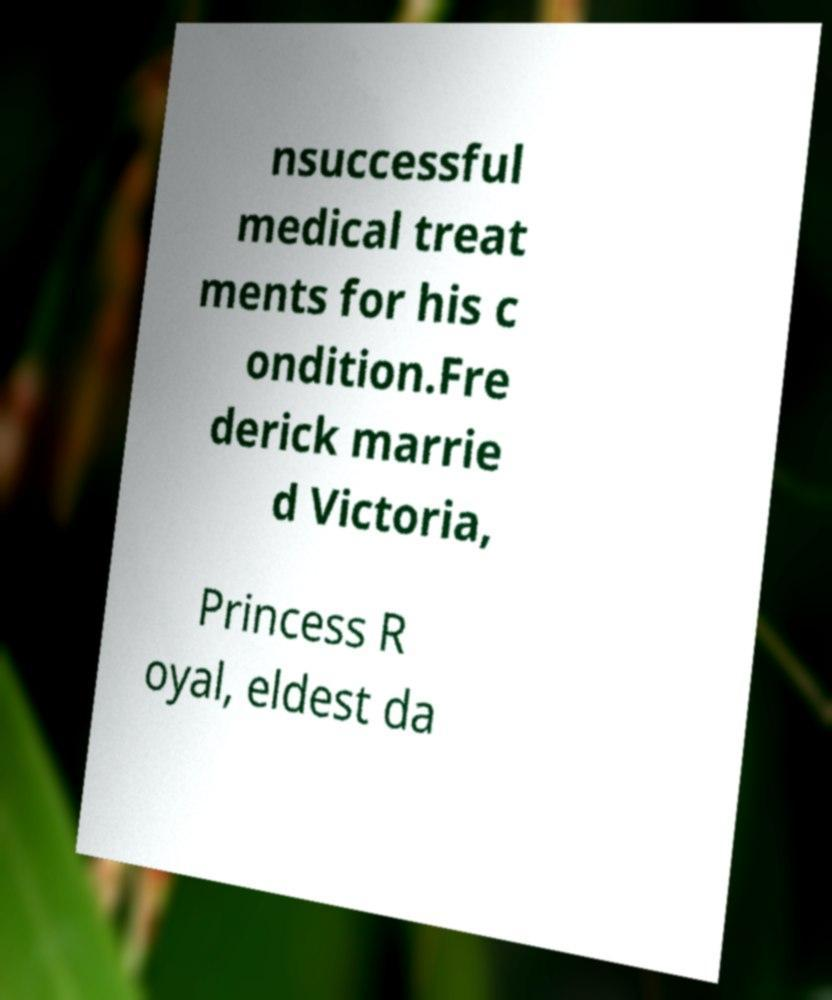Could you extract and type out the text from this image? nsuccessful medical treat ments for his c ondition.Fre derick marrie d Victoria, Princess R oyal, eldest da 